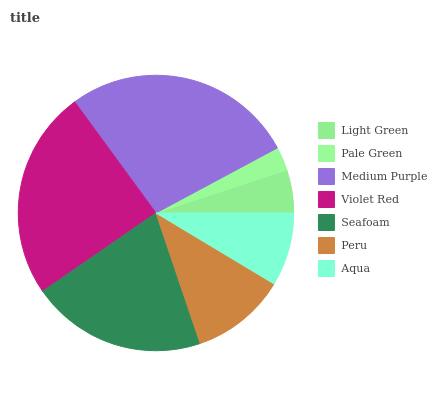Is Pale Green the minimum?
Answer yes or no. Yes. Is Medium Purple the maximum?
Answer yes or no. Yes. Is Medium Purple the minimum?
Answer yes or no. No. Is Pale Green the maximum?
Answer yes or no. No. Is Medium Purple greater than Pale Green?
Answer yes or no. Yes. Is Pale Green less than Medium Purple?
Answer yes or no. Yes. Is Pale Green greater than Medium Purple?
Answer yes or no. No. Is Medium Purple less than Pale Green?
Answer yes or no. No. Is Peru the high median?
Answer yes or no. Yes. Is Peru the low median?
Answer yes or no. Yes. Is Violet Red the high median?
Answer yes or no. No. Is Medium Purple the low median?
Answer yes or no. No. 